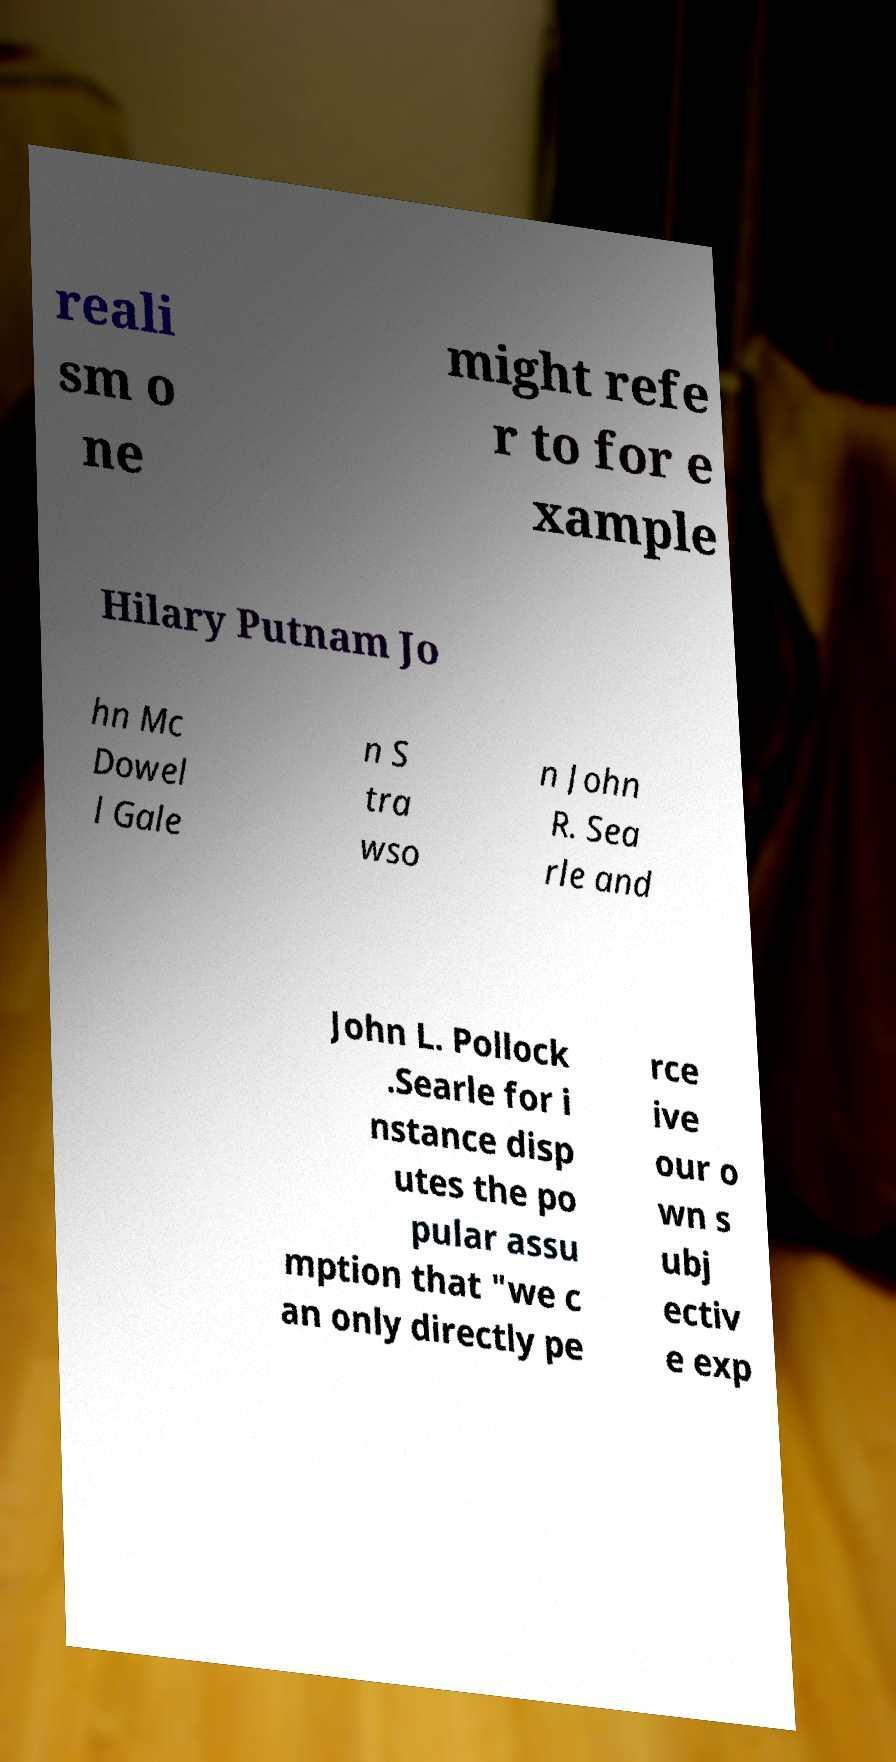I need the written content from this picture converted into text. Can you do that? reali sm o ne might refe r to for e xample Hilary Putnam Jo hn Mc Dowel l Gale n S tra wso n John R. Sea rle and John L. Pollock .Searle for i nstance disp utes the po pular assu mption that "we c an only directly pe rce ive our o wn s ubj ectiv e exp 